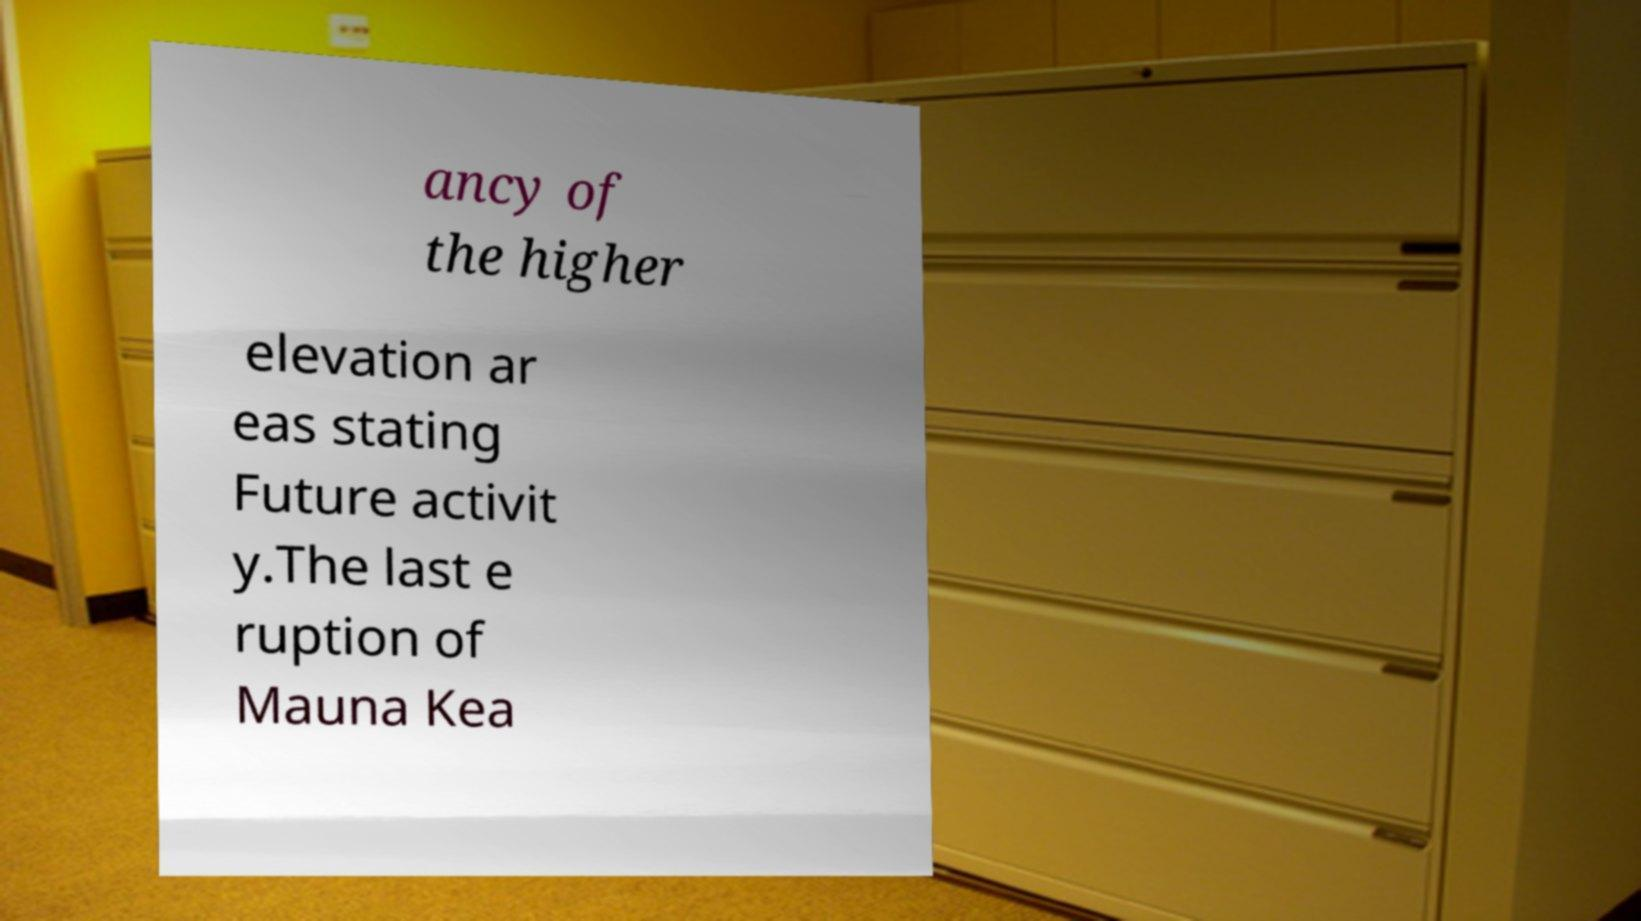Please read and relay the text visible in this image. What does it say? ancy of the higher elevation ar eas stating Future activit y.The last e ruption of Mauna Kea 